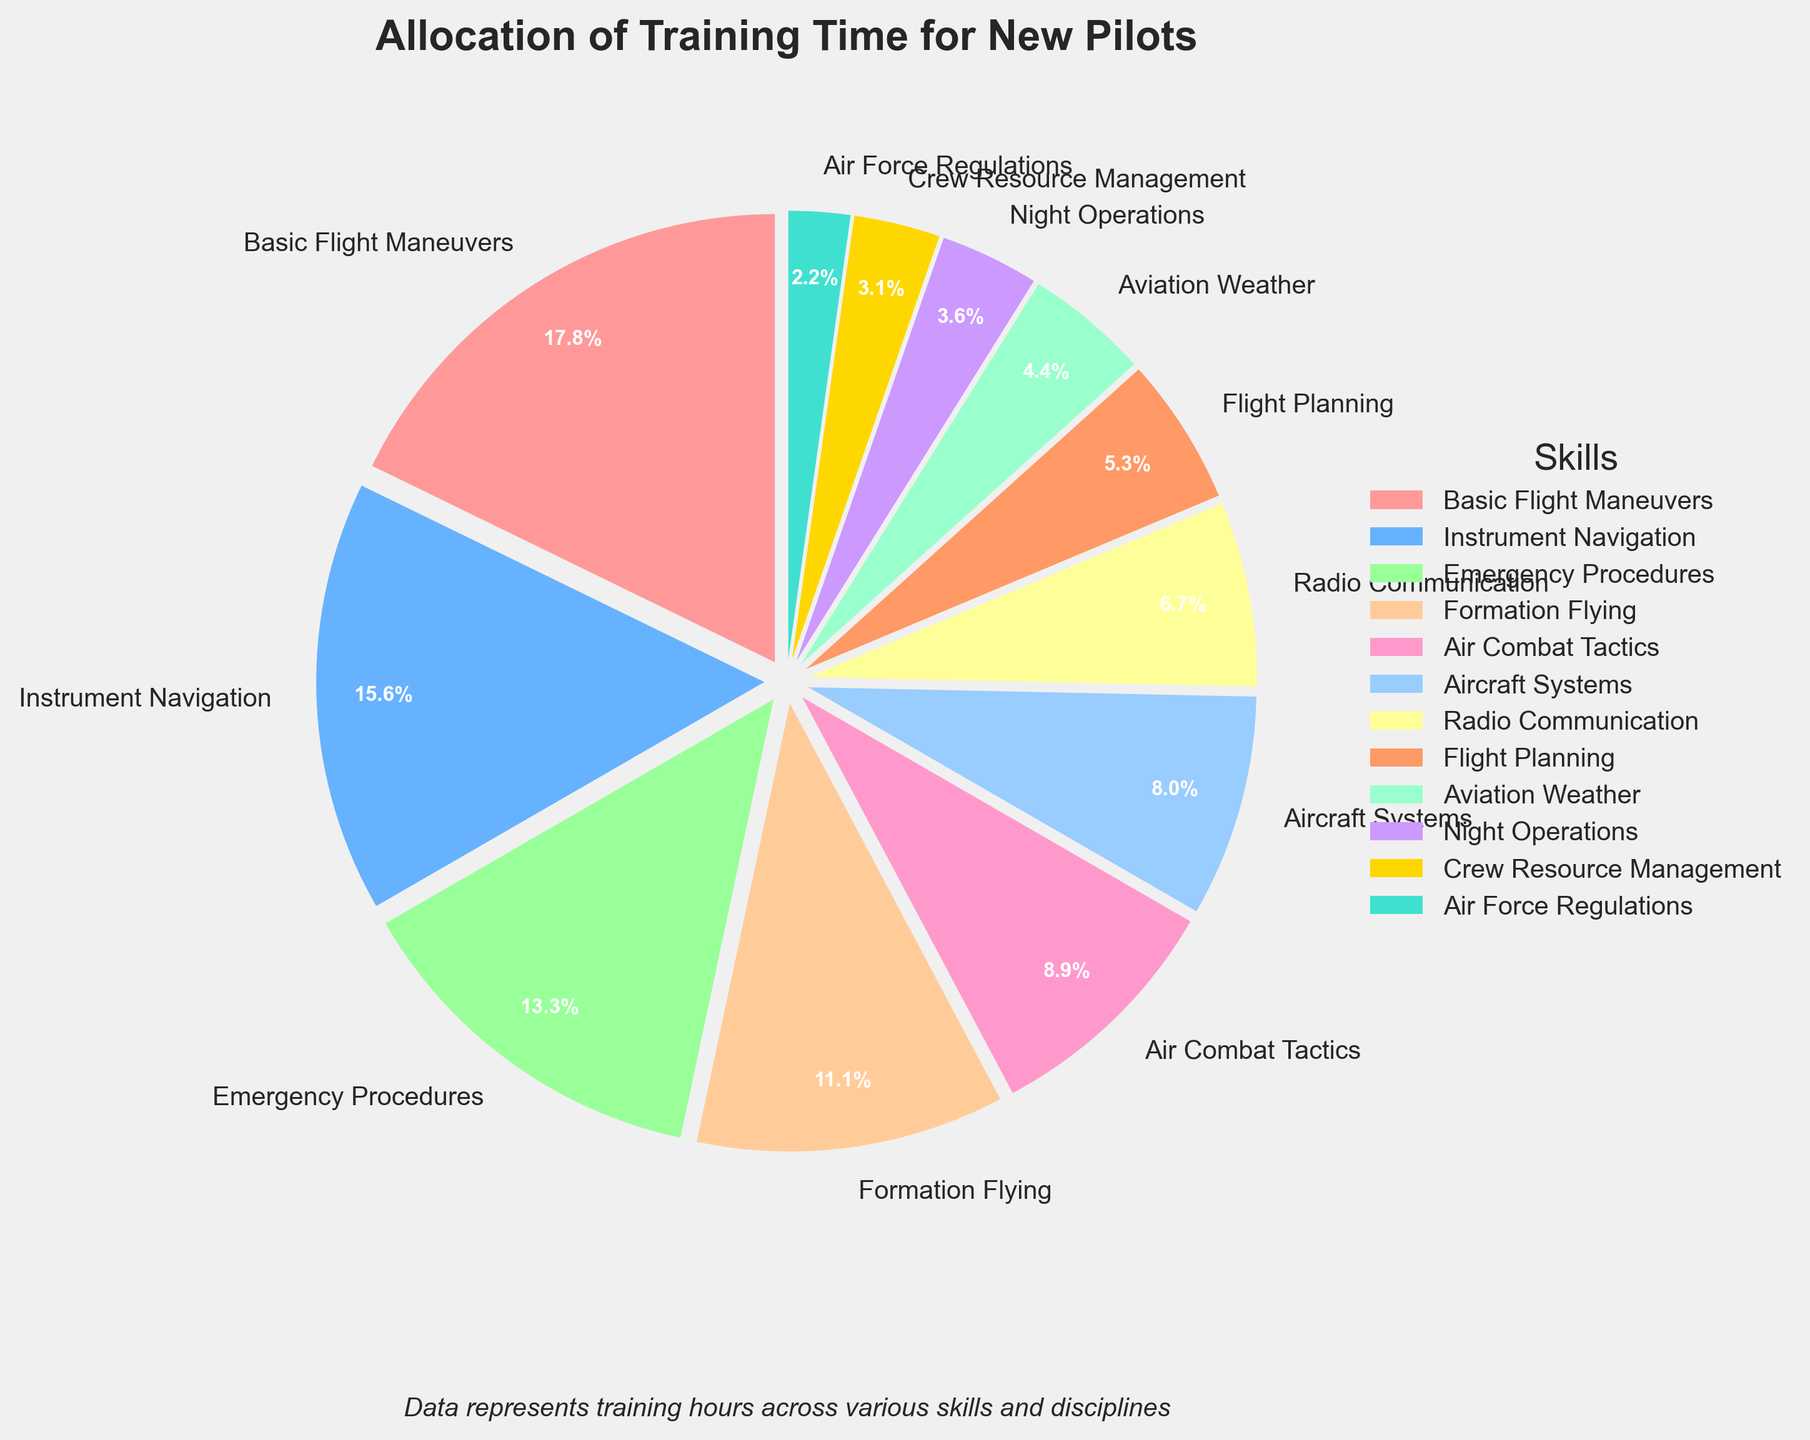What's the percentage of training time allocated to Basic Flight Maneuvers? By referencing the pie chart, observe the slice labeled "Basic Flight Maneuvers" and check the percentage indicated.
Answer: 25.4% How much more training time is spent on Basic Flight Maneuvers than on Air Force Regulations? Look at the hours for each skill: Basic Flight Maneuvers (40 hours) and Air Force Regulations (5 hours). The difference is 40 - 5 = 35 hours.
Answer: 35 hours Which skill has the least training time and what percent does it represent? Refer to the smallest slice of the pie chart. The label shows "Air Force Regulations" with a specific percentage.
Answer: Air Force Regulations, 3.2% If we combine the training hours for Instrument Navigation and Emergency Procedures, how many hours do we get? Add the hours for Instrument Navigation (35 hours) and Emergency Procedures (30 hours). The sum is 35 + 30 = 65 hours.
Answer: 65 hours Which skill has more training hours allocated, Formation Flying or Aircraft Systems? Check the training hours for both skills: Formation Flying (25 hours) and Aircraft Systems (18 hours). Formation Flying has more hours.
Answer: Formation Flying What percent of the training is allocated to Night Operations? Refer to the pie chart slice labeled "Night Operations" and note the percentage listed.
Answer: 5.1% How does training time for Emergency Procedures compare to Air Combat Tactics in terms of hours? Look at the hours: Emergency Procedures (30 hours) and Air Combat Tactics (20 hours). Emergency Procedures has 10 hours more.
Answer: 10 hours more What is the total percentage of training time allocated to Safety-related skills (Emergency Procedures, Crew Resource Management, and Aviation Weather)? Sum the percentages from the chart: Emergency Procedures (19.0%), Crew Resource Management (4.4%), and Aviation Weather (6.3%). The total is 19.0 + 4.4 + 6.3 = 29.7%.
Answer: 29.7% Which skill takes up the largest proportion of training time, and what color represents it in the chart? Identify the largest slice in the pie chart and note its label and color. "Basic Flight Maneuvers" is the largest, represented by a specific color.
Answer: Basic Flight Maneuvers, red 